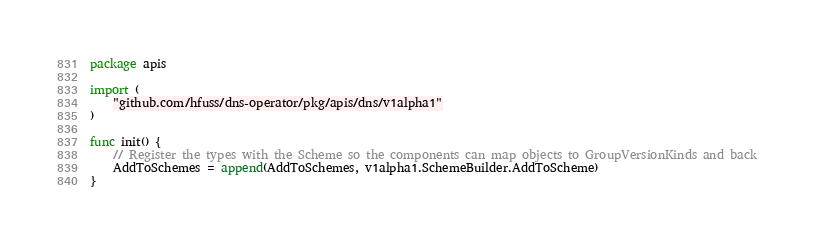Convert code to text. <code><loc_0><loc_0><loc_500><loc_500><_Go_>package apis

import (
	"github.com/hfuss/dns-operator/pkg/apis/dns/v1alpha1"
)

func init() {
	// Register the types with the Scheme so the components can map objects to GroupVersionKinds and back
	AddToSchemes = append(AddToSchemes, v1alpha1.SchemeBuilder.AddToScheme)
}
</code> 